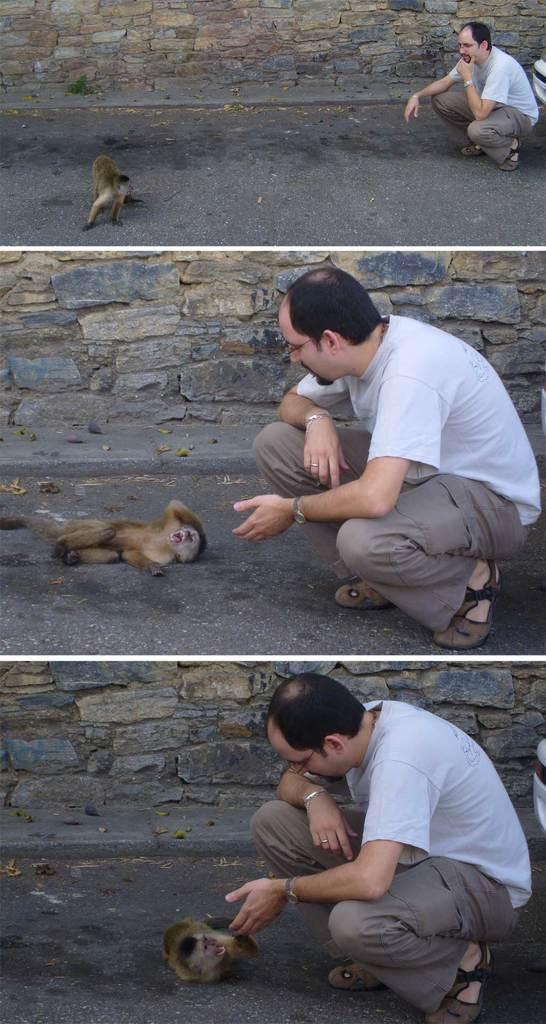What type of artwork is the image? The image is a collage. What animals or people are depicted in the collage? There is an image of a monkey and an image of a person in the collage. What verse is being recited by the monkey in the image? There is no verse being recited by the monkey in the image, as it is a still image and not a video or audio recording. 